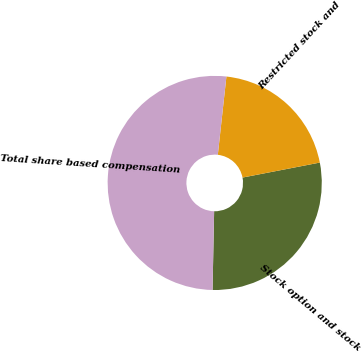<chart> <loc_0><loc_0><loc_500><loc_500><pie_chart><fcel>Stock option and stock<fcel>Restricted stock and<fcel>Total share based compensation<nl><fcel>28.37%<fcel>20.21%<fcel>51.42%<nl></chart> 